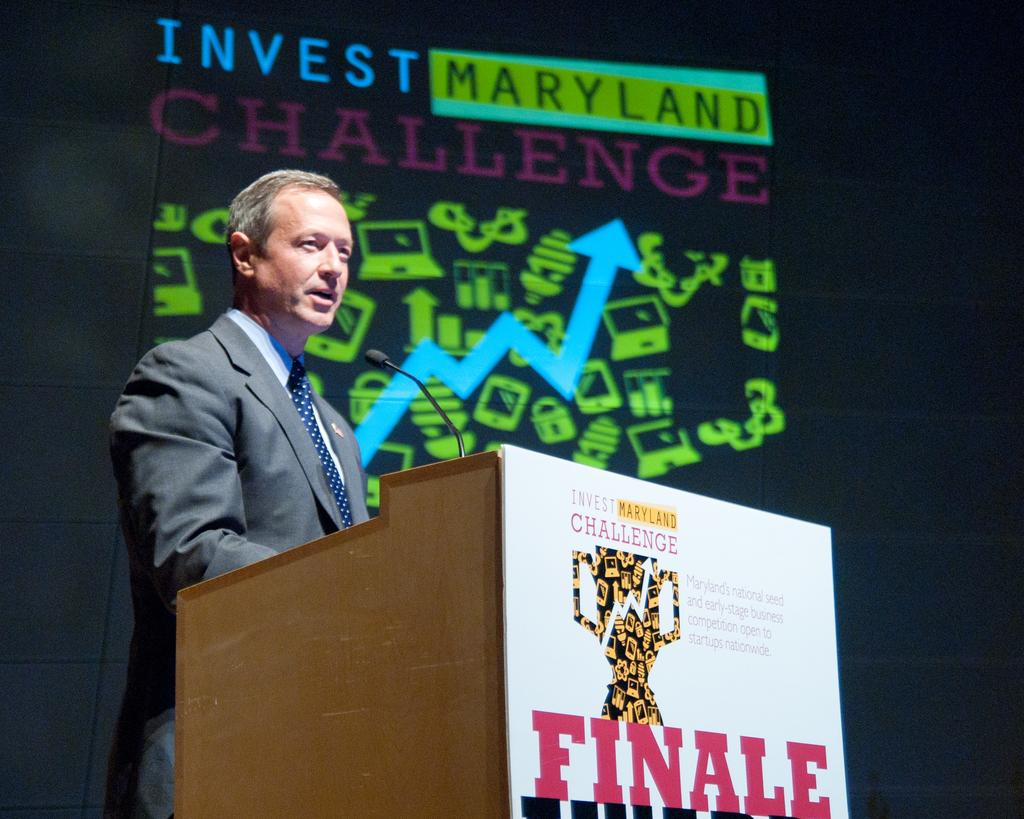What is the person in the image doing? There is a person standing at a desk in the image. What object is on the desk with the person? There is a mic on the desk in the image. What can be seen in the background of the image? There is an advertisement and a wall in the background of the image. What type of silver bat is hanging on the wall in the image? There is no silver bat present in the image; the wall in the background does not have any bats hanging on it. 